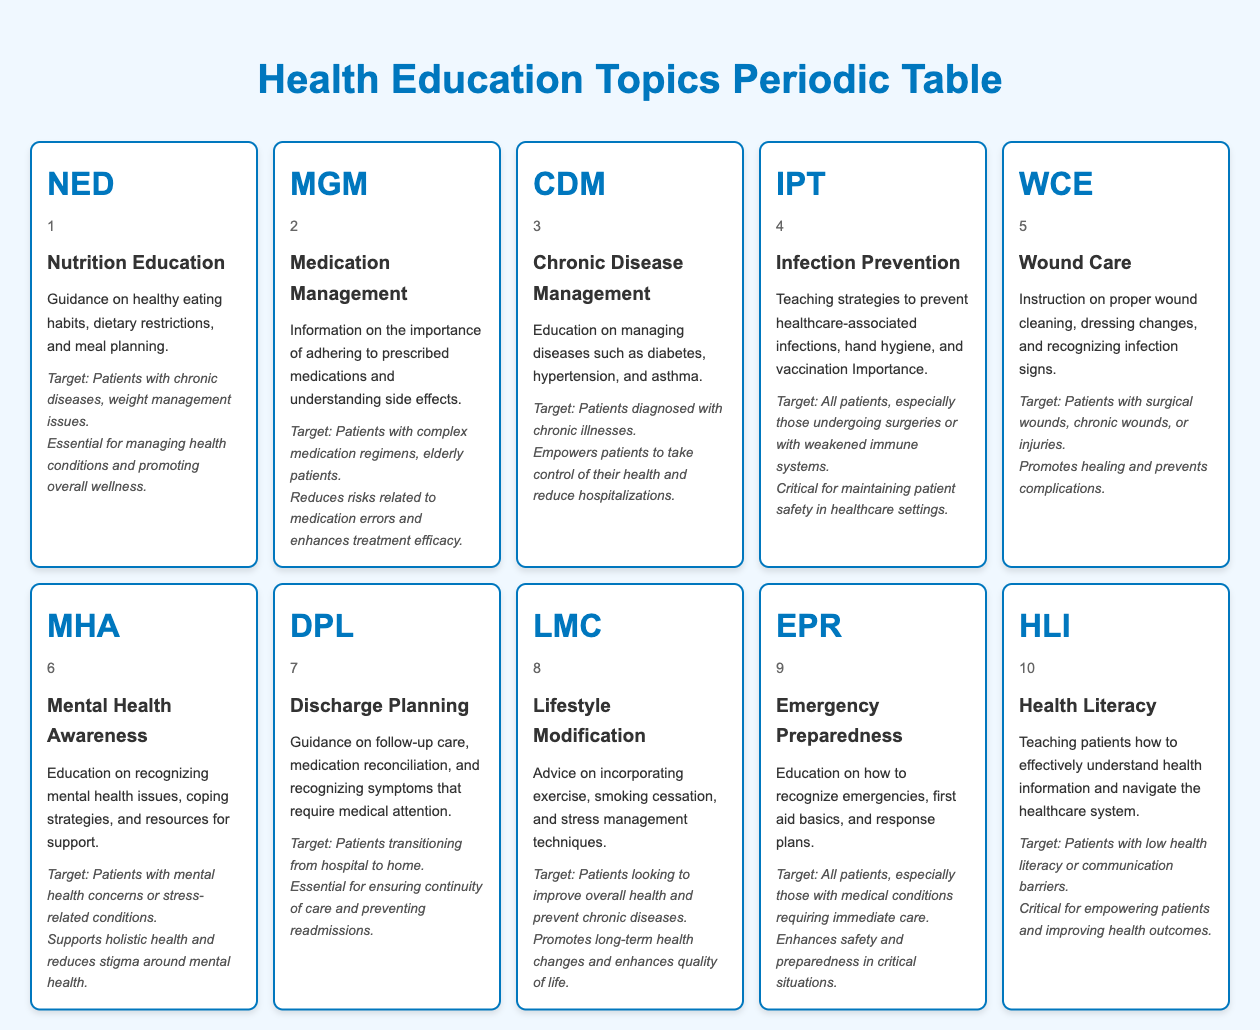What is the primary target audience for Nutrition Education? The target audience for Nutrition Education is specified in the table as "Patients with chronic diseases, weight management issues."
Answer: Patients with chronic diseases, weight management issues Which health education topic focuses on empowering patients to manage chronic illnesses? The health education topic that focuses on empowering patients with chronic illnesses is Chronic Disease Management. This is indicated in the table under the description given for that topic.
Answer: Chronic Disease Management Is Infection Prevention important for all patients? Yes, the table states that Infection Prevention is critical for "All patients, especially those undergoing surgeries or with weakened immune systems." Therefore, it applies to the entire patient population.
Answer: Yes How many different health education topics have a target audience of elderly patients? The table indicates that only the topic Medication Management explicitly targets "Patients with complex medication regimens, elderly patients." Hence, there is just one topic for the elderly.
Answer: 1 What is the importance of Health Literacy in patient care? Health Literacy is described in the table as "Critical for empowering patients and improving health outcomes." This importance suggests that understanding health information is essential for patients.
Answer: Critical for empowering patients and improving health outcomes List the health education topics that emphasize mental health. According to the table, the only health education topic that specifically addresses mental health is Mental Health Awareness, as detailed in its description which mentions recognizing mental health issues.
Answer: Mental Health Awareness What is the importance of Wound Care compared to Lifestyle Modification? Wound Care's importance is "Promotes healing and prevents complications," while Lifestyle Modification states it "Promotes long-term health changes and enhances quality of life." Both are important but focus on different aspects of health, so one isn't strictly more important than the other.
Answer: They focus on different health aspects Which health education topic involves teaching patients about emergency first aid? The topic that covers emergency first aid education is Emergency Preparedness, as noted in the description where it mentions "first aid basics."
Answer: Emergency Preparedness 